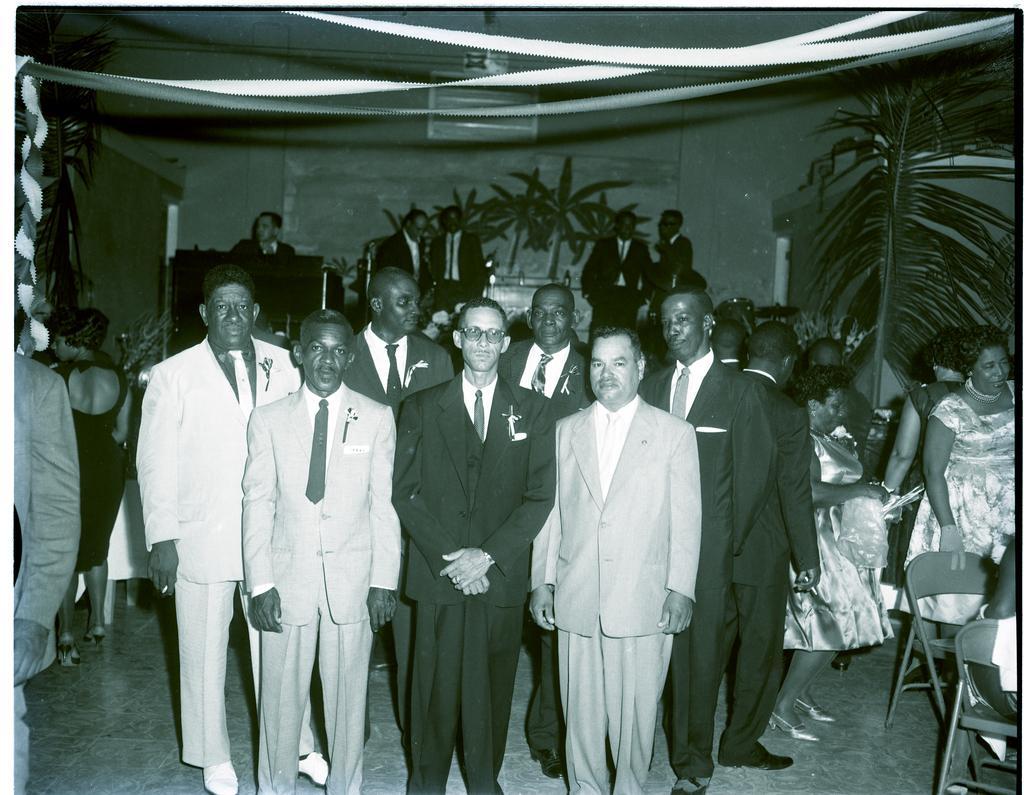How would you summarize this image in a sentence or two? In this image we can see a group of persons. Behind the persons we can a podium and a wall. On the wall we can see a banner and in the banner we can see trees. On the right side, we can see chairs and a branch of a tree. On the left side, we can see decorative items and leaves. At the top we can see the decorative items. 